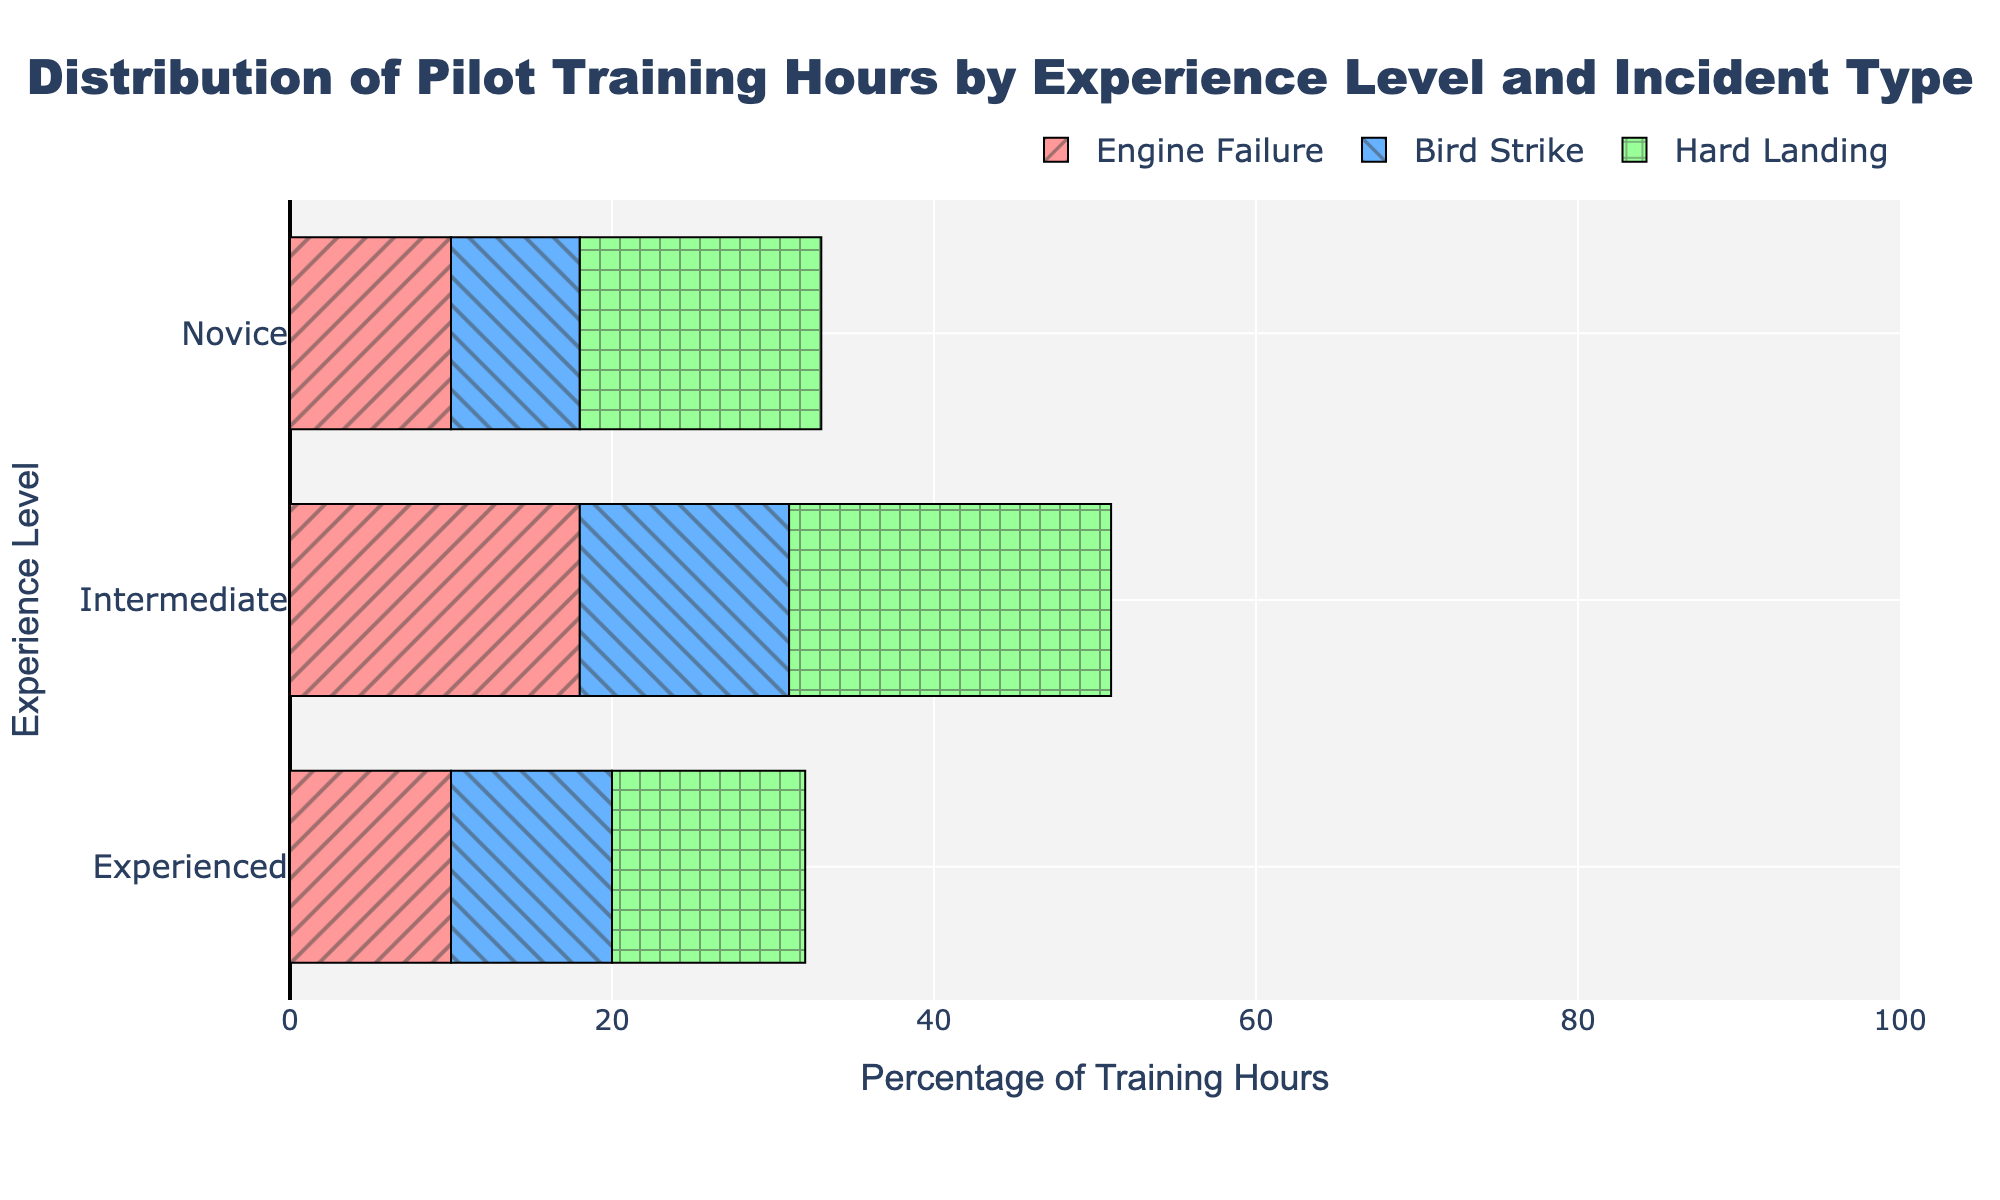How many more training hours in percentage do novice pilots spend on hard landings compared to bird strikes? Novice pilots spend 15% of their training hours on hard landings and 8% on bird strikes. The difference is 15% - 8% = 7%.
Answer: 7% Which experience level has the highest percentage of training hours spent on engine failure? By comparing the bars, intermediate pilots have the highest percentage, with 18%. Novice and experienced pilots both have lower percentages.
Answer: Intermediate Is the percentage of training hours spent on bird strikes the same for novice and experienced pilots? The percentage for novice pilots is 8%, while for experienced pilots it is 10%. Therefore, they are not the same.
Answer: No What is the total percentage of training hours spent on hard landings across all experience levels? Sum the percentages for hard landings: Novice (15%) + Intermediate (20%) + Experienced (12%) = 47%.
Answer: 47% Which incident type is represented by the bar with the diagonal stripes pattern, and what does it indicate for intermediate pilots? The diagonal stripes pattern corresponds to bird strikes. For intermediate pilots, it indicates 13% of their training hours.
Answer: Bird Strikes, 13% Compare the training hours distribution between novice and experienced pilots for engine failure. Novice pilots spend 10% of their training hours on engine failure, while experienced pilots spend the same amount: 10%. Therefore, the distribution is equal.
Answer: Equal How does the training hours distribution for hard landings differ between novice and intermediate pilots? Novice pilots spend 15% on hard landings, whereas intermediate pilots spend 20%. The difference is 20% - 15% = 5%.
Answer: 5% Which colored bar represents the incident type with the lowest percentage for experienced pilots, and what is the percentage? The green bar represents bird strikes for experienced pilots, showing a percentage of 10%.
Answer: Green, 10% 